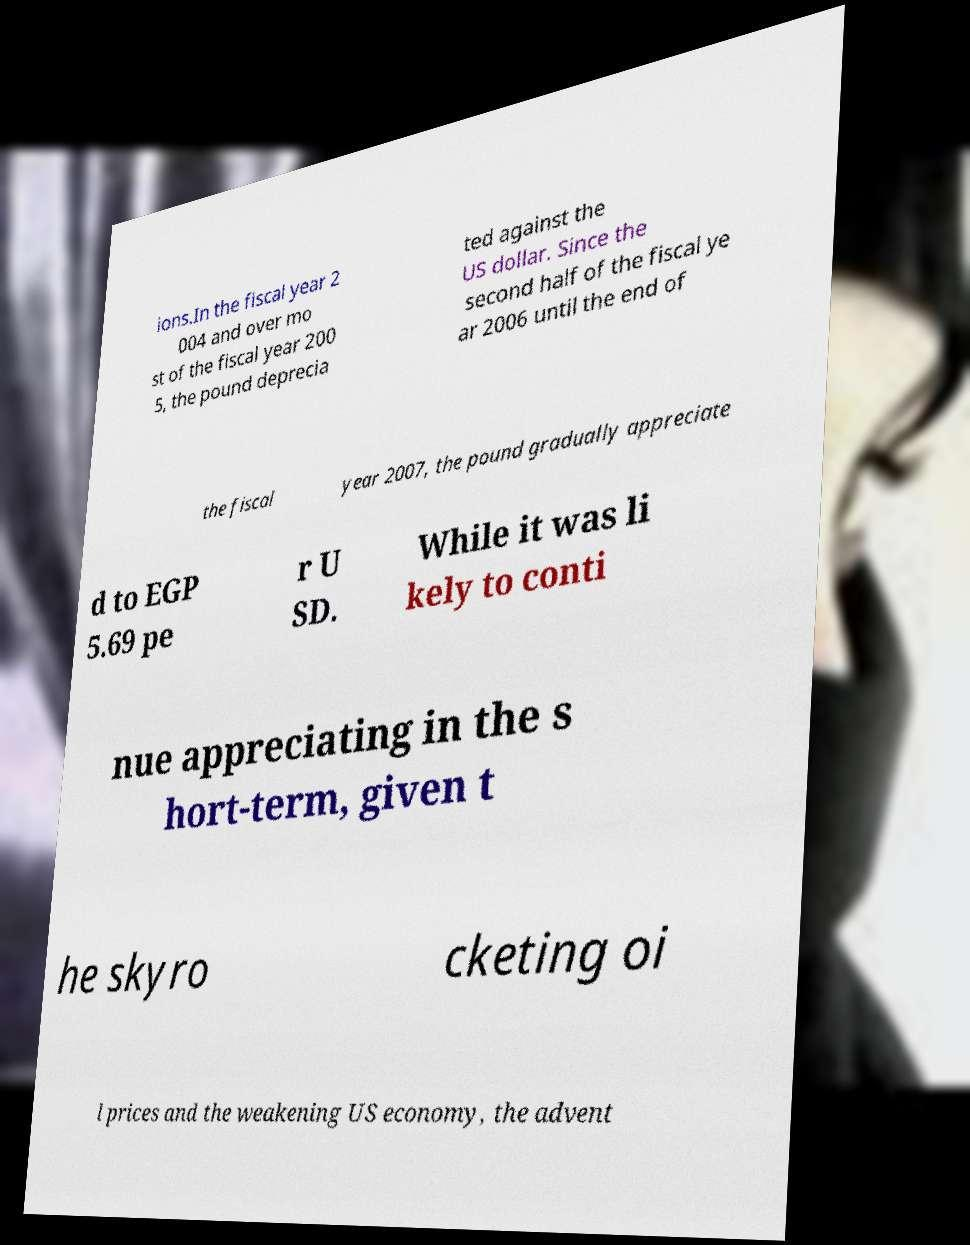Could you assist in decoding the text presented in this image and type it out clearly? ions.In the fiscal year 2 004 and over mo st of the fiscal year 200 5, the pound deprecia ted against the US dollar. Since the second half of the fiscal ye ar 2006 until the end of the fiscal year 2007, the pound gradually appreciate d to EGP 5.69 pe r U SD. While it was li kely to conti nue appreciating in the s hort-term, given t he skyro cketing oi l prices and the weakening US economy, the advent 